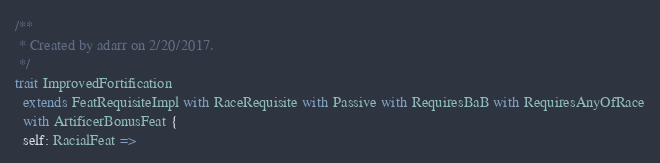<code> <loc_0><loc_0><loc_500><loc_500><_Scala_>
/**
 * Created by adarr on 2/20/2017.
 */
trait ImprovedFortification
  extends FeatRequisiteImpl with RaceRequisite with Passive with RequiresBaB with RequiresAnyOfRace
  with ArtificerBonusFeat {
  self: RacialFeat =></code> 